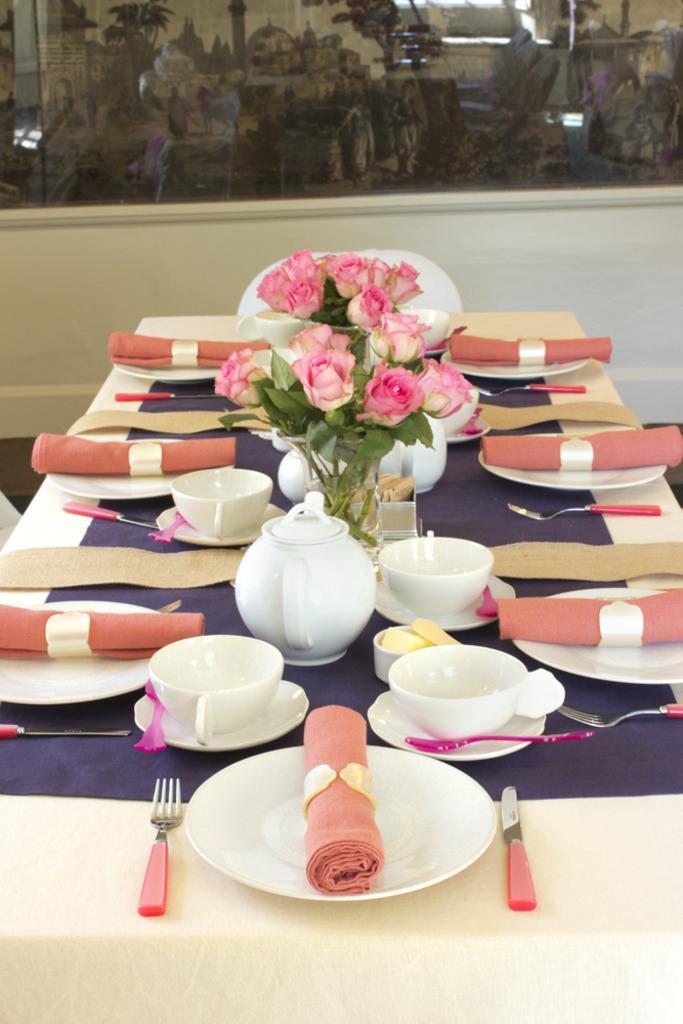Can you describe this image briefly? In this picture we can see table and on table we have plate, forks, cup, saucer, bowl, teapot, vase with flowers, cloth on plates and in background we can see glass wall. 